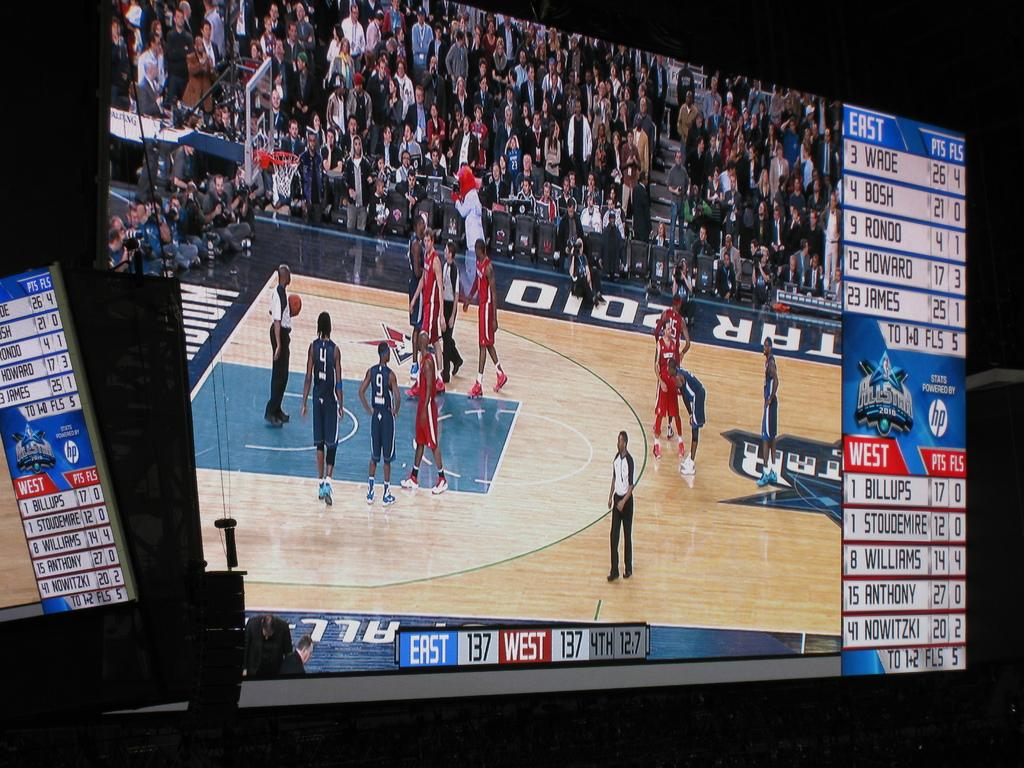<image>
Share a concise interpretation of the image provided. The basketball game is about the East vs West 